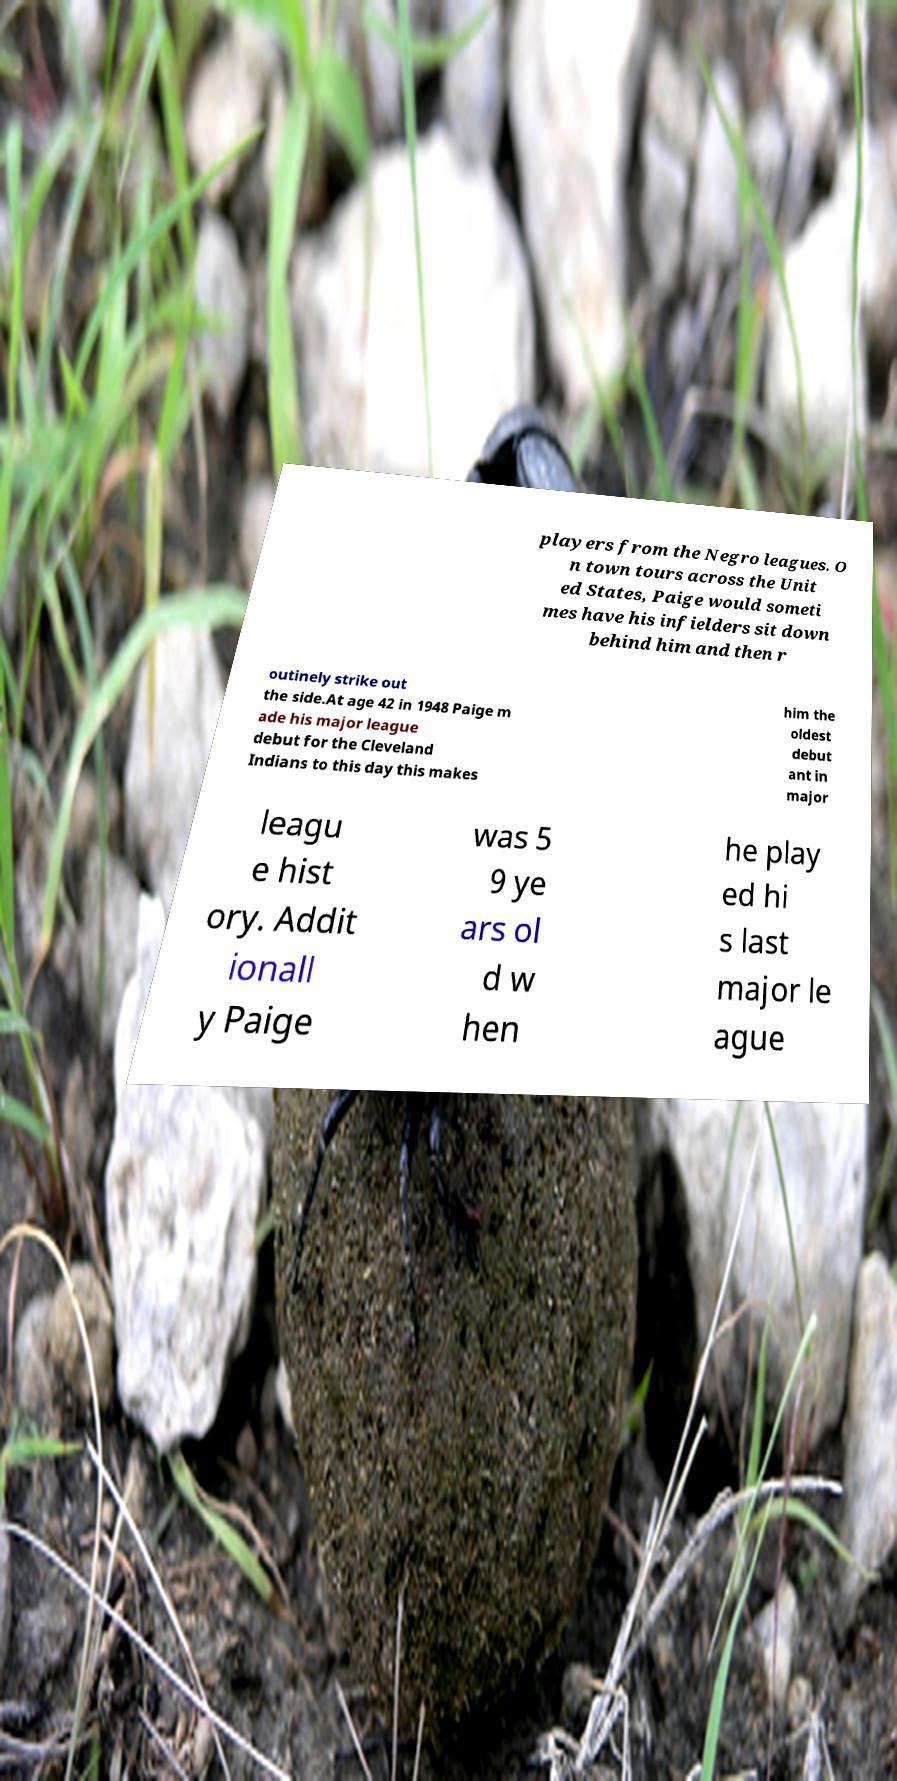Please identify and transcribe the text found in this image. players from the Negro leagues. O n town tours across the Unit ed States, Paige would someti mes have his infielders sit down behind him and then r outinely strike out the side.At age 42 in 1948 Paige m ade his major league debut for the Cleveland Indians to this day this makes him the oldest debut ant in major leagu e hist ory. Addit ionall y Paige was 5 9 ye ars ol d w hen he play ed hi s last major le ague 